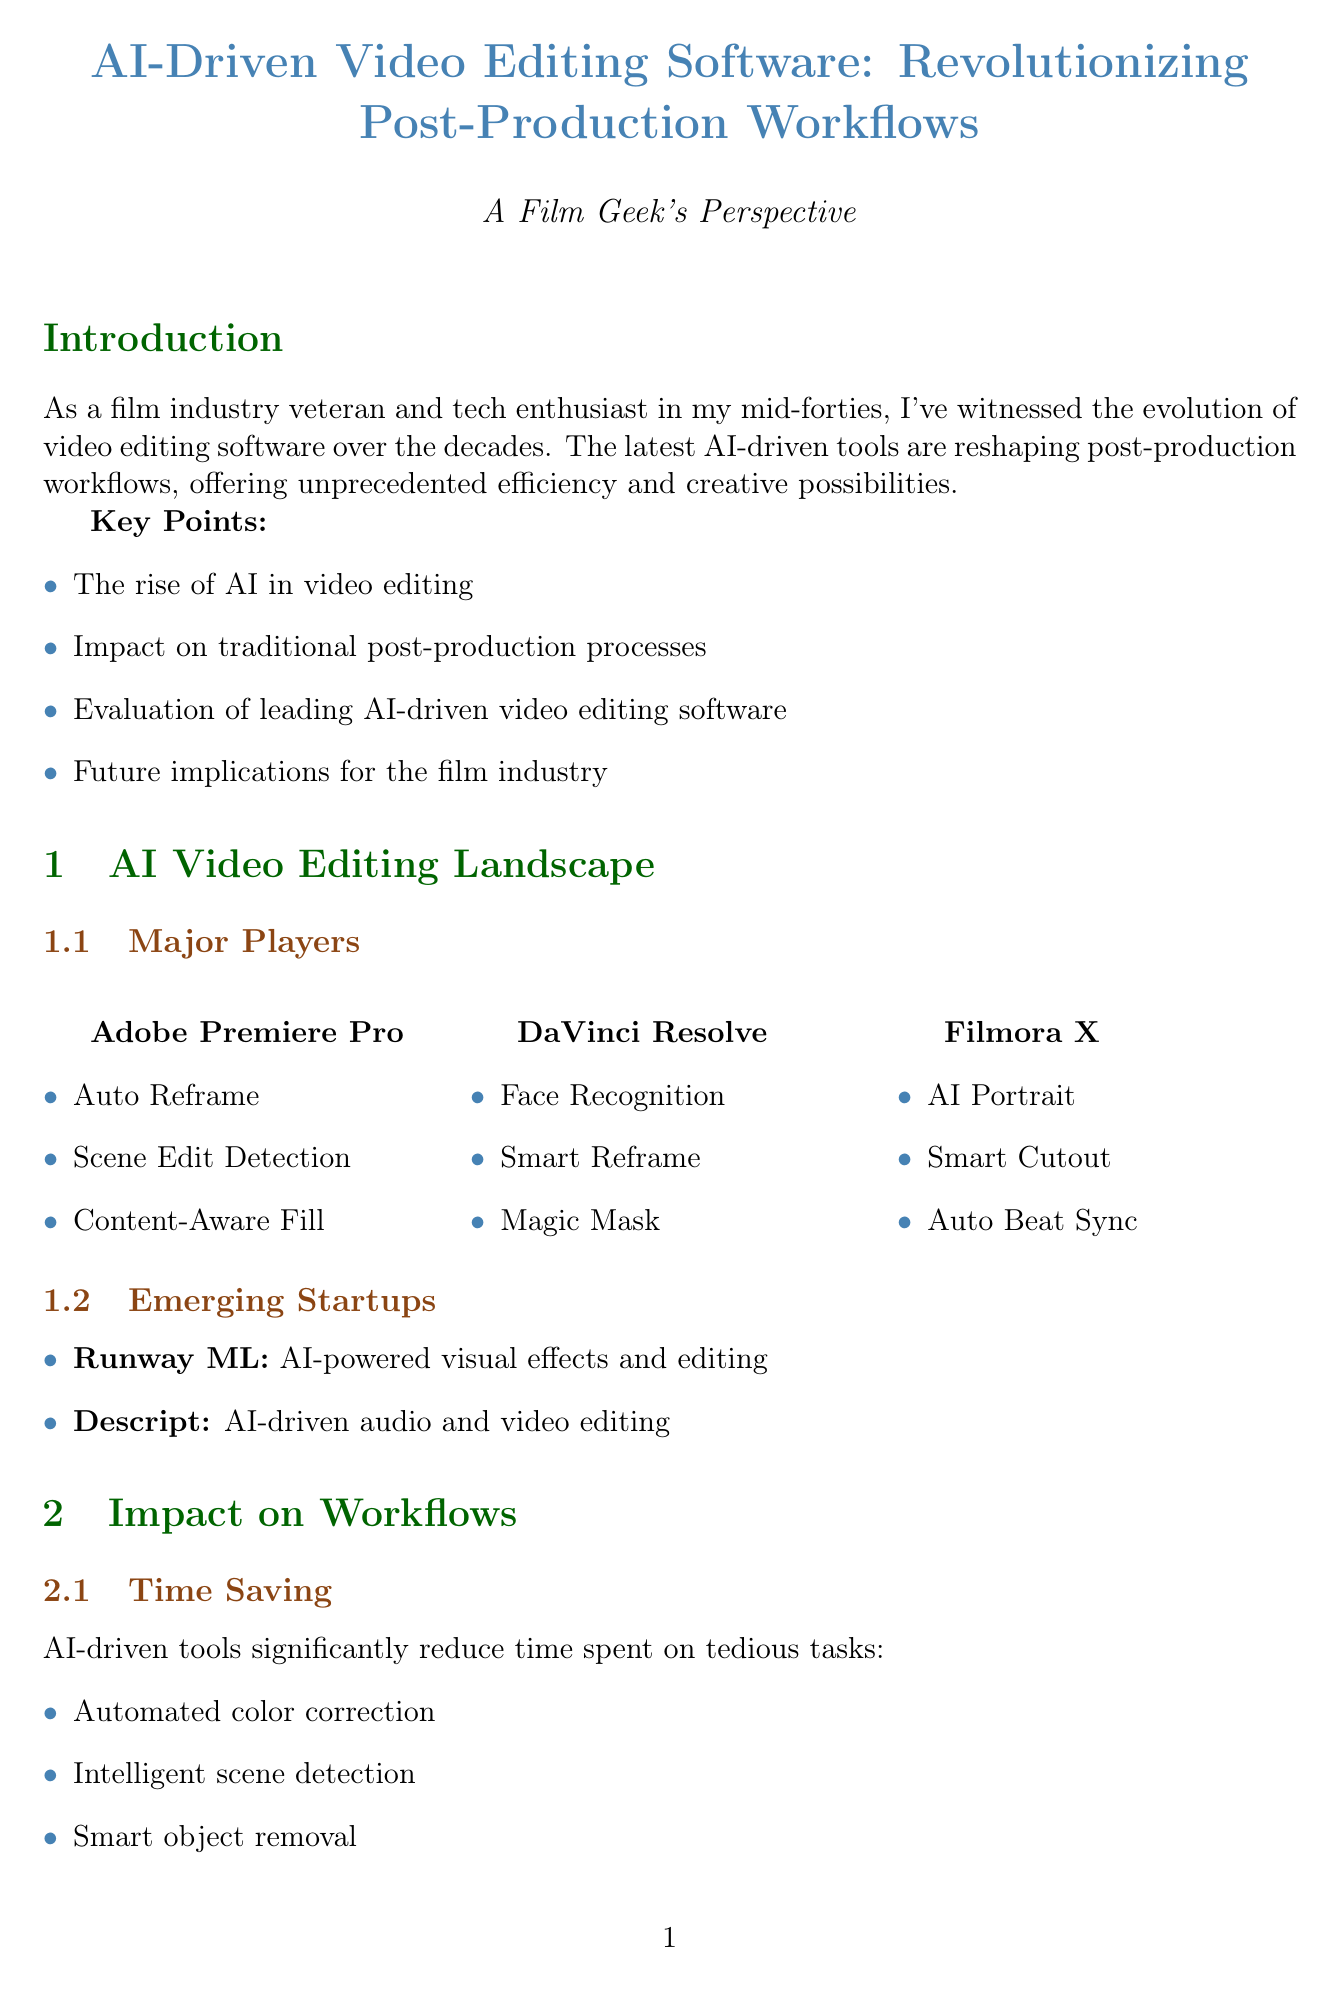What are the key points of the introduction? The key points are listed in the introduction section and include topics that summarize the emerging trend of AI in video editing.
Answer: The rise of AI in video editing, Impact on traditional post-production processes, Evaluation of leading AI-driven video editing software, Future implications for the film industry Which software has AI features for Face Recognition? This is a specific feature of one of the major video editing software discussed in the document.
Answer: DaVinci Resolve What is one con of Adobe Premiere Pro? This refers to the downsides identified in the software evaluation section regarding Adobe Premiere Pro.
Answer: Steep learning curve for new users How does AI contribute to time-saving in video editing? The document outlines specific ways AI reduces the time spent on tasks, an essential factor in workflow efficiency.
Answer: Automated color correction What future implication is related to the creative process? The document discusses how different factors will influence the creative processes in video editing due to AI.
Answer: AI as a collaborative creative partner Which emerging startup specializes in AI-driven audio and video editing? This question focuses on identifying new entrants in the market as discussed in the document.
Answer: Descript What kind of roles might increase in the job market due to AI in editing? The report mentions specific shifts in the job market related to AI technologies in video editing.
Answer: AI supervision roles What is a reason why DaVinci Resolve's interface is challenging for beginners? This question sources the software evaluation section and highlights user experience related to the software.
Answer: Complex interface for beginners 